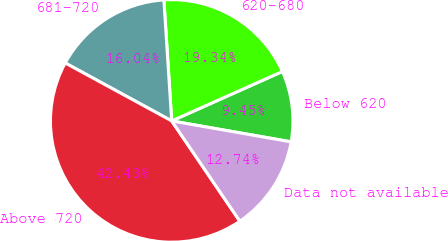Convert chart to OTSL. <chart><loc_0><loc_0><loc_500><loc_500><pie_chart><fcel>Below 620<fcel>620-680<fcel>681-720<fcel>Above 720<fcel>Data not available<nl><fcel>9.45%<fcel>19.34%<fcel>16.04%<fcel>42.43%<fcel>12.74%<nl></chart> 